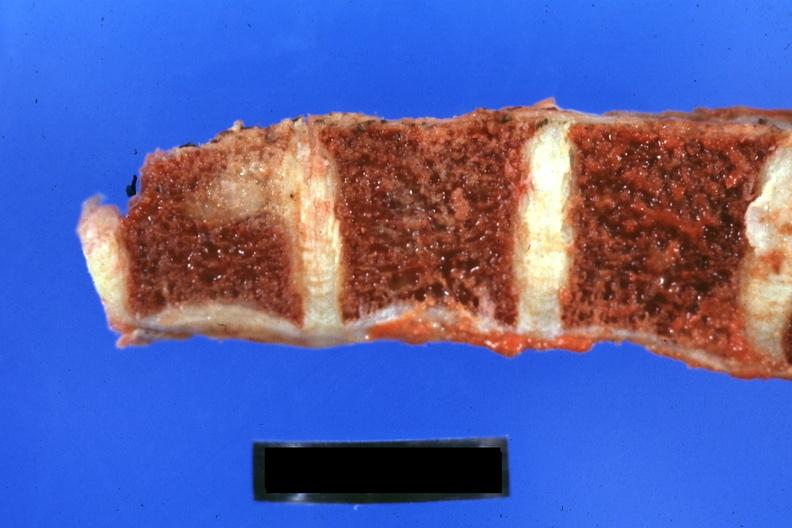what occurring 25 years after she was treat-ed for hodgkins disease?
Answer the question using a single word or phrase. Obvious metastatic lesion 44yobfadenocarcinoma of lung giant cell type 